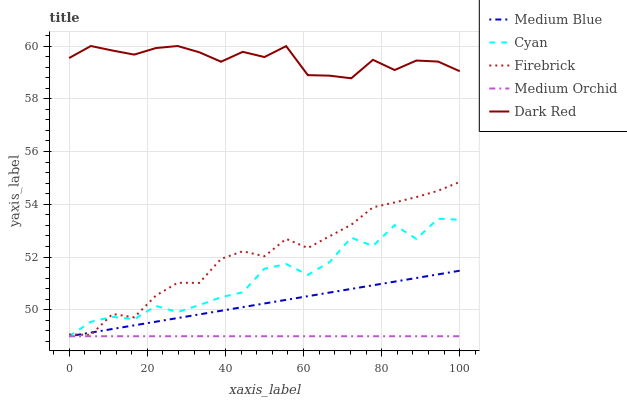Does Medium Orchid have the minimum area under the curve?
Answer yes or no. Yes. Does Dark Red have the maximum area under the curve?
Answer yes or no. Yes. Does Firebrick have the minimum area under the curve?
Answer yes or no. No. Does Firebrick have the maximum area under the curve?
Answer yes or no. No. Is Medium Blue the smoothest?
Answer yes or no. Yes. Is Cyan the roughest?
Answer yes or no. Yes. Is Firebrick the smoothest?
Answer yes or no. No. Is Firebrick the roughest?
Answer yes or no. No. Does Cyan have the lowest value?
Answer yes or no. Yes. Does Firebrick have the lowest value?
Answer yes or no. No. Does Dark Red have the highest value?
Answer yes or no. Yes. Does Firebrick have the highest value?
Answer yes or no. No. Is Firebrick less than Dark Red?
Answer yes or no. Yes. Is Firebrick greater than Medium Orchid?
Answer yes or no. Yes. Does Medium Orchid intersect Medium Blue?
Answer yes or no. Yes. Is Medium Orchid less than Medium Blue?
Answer yes or no. No. Is Medium Orchid greater than Medium Blue?
Answer yes or no. No. Does Firebrick intersect Dark Red?
Answer yes or no. No. 